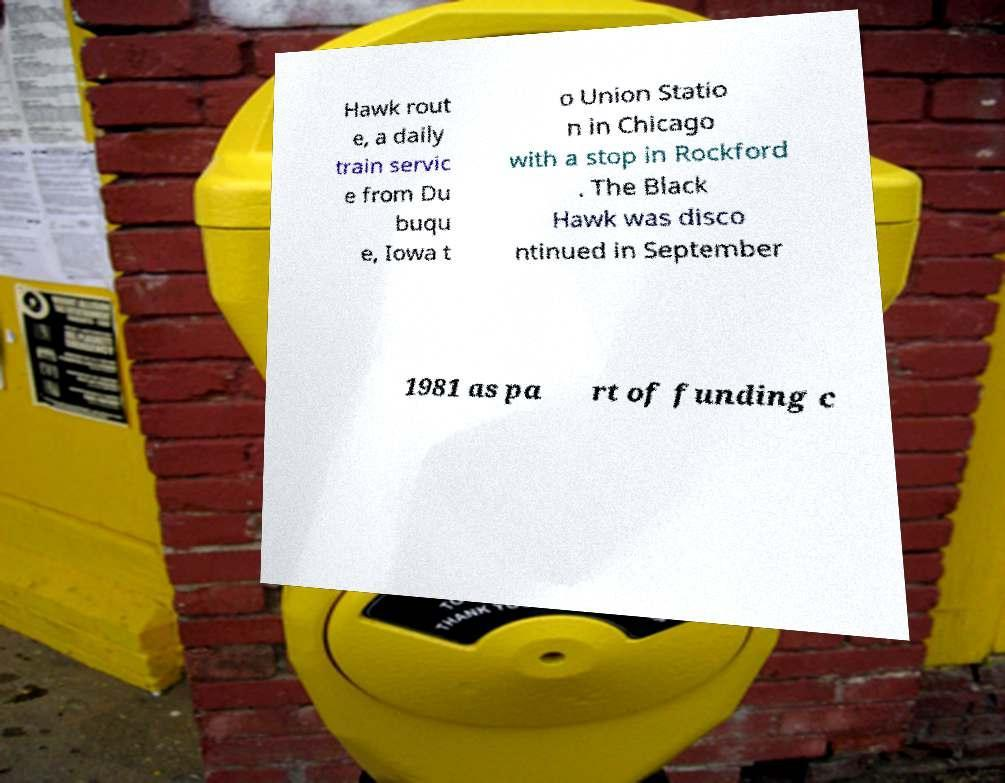Could you assist in decoding the text presented in this image and type it out clearly? Hawk rout e, a daily train servic e from Du buqu e, Iowa t o Union Statio n in Chicago with a stop in Rockford . The Black Hawk was disco ntinued in September 1981 as pa rt of funding c 